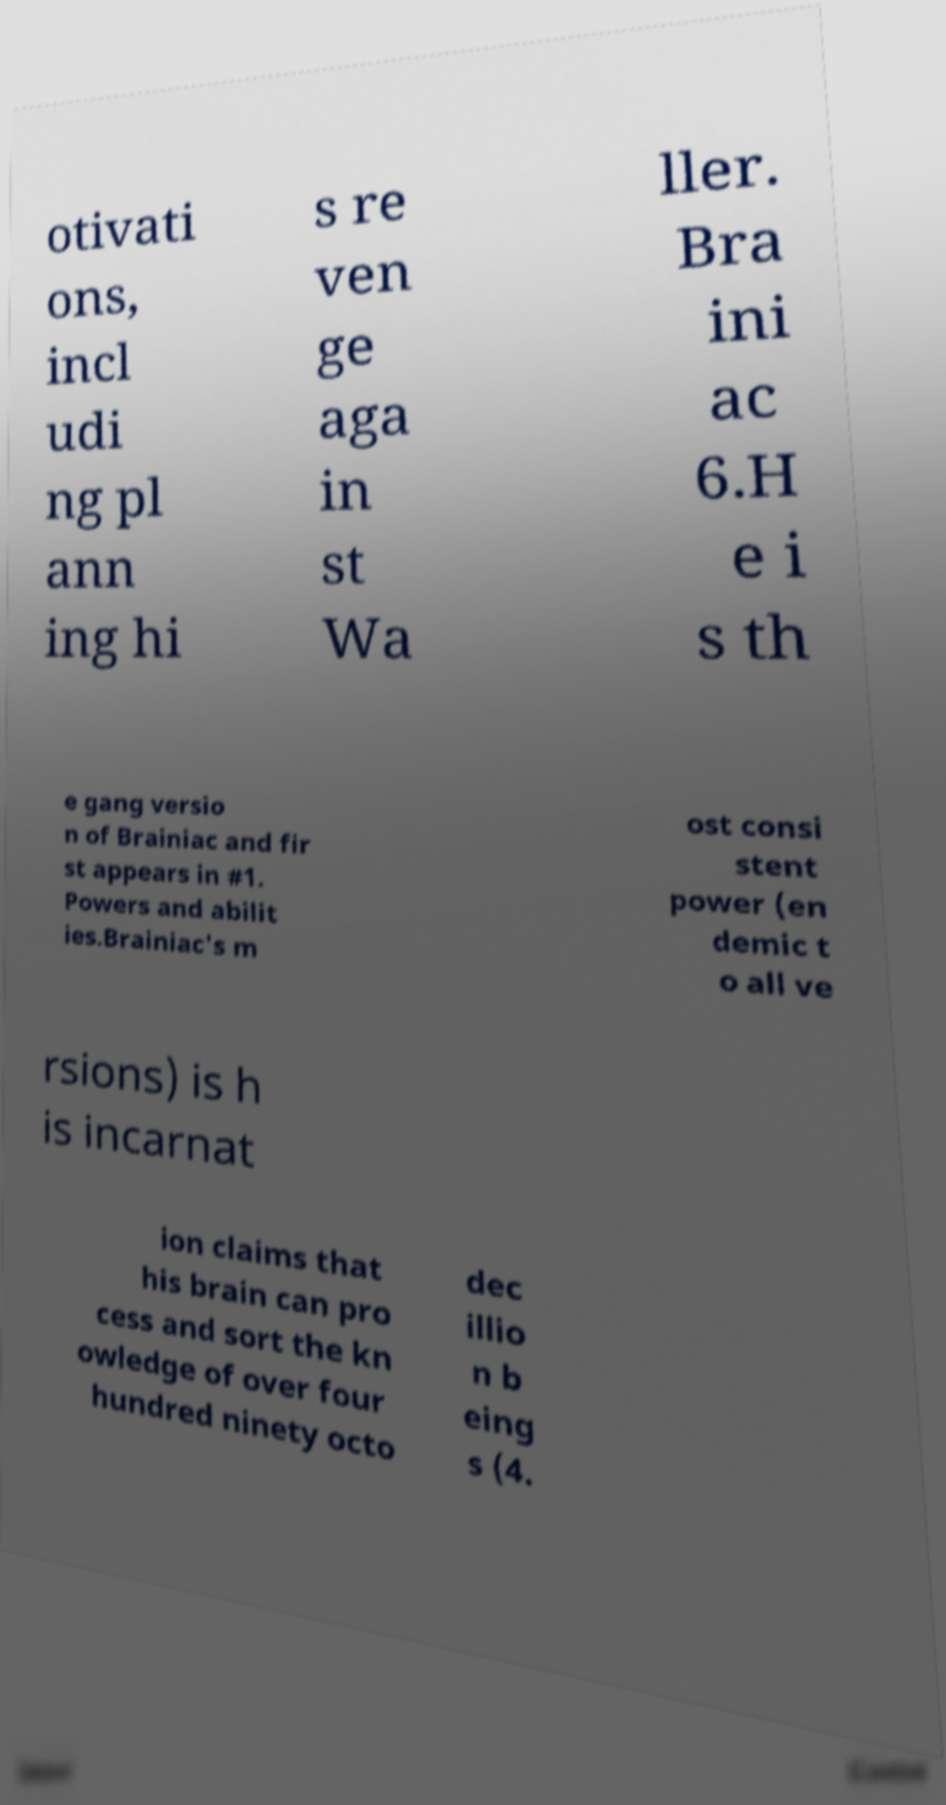I need the written content from this picture converted into text. Can you do that? otivati ons, incl udi ng pl ann ing hi s re ven ge aga in st Wa ller. Bra ini ac 6.H e i s th e gang versio n of Brainiac and fir st appears in #1. Powers and abilit ies.Brainiac's m ost consi stent power (en demic t o all ve rsions) is h is incarnat ion claims that his brain can pro cess and sort the kn owledge of over four hundred ninety octo dec illio n b eing s (4. 